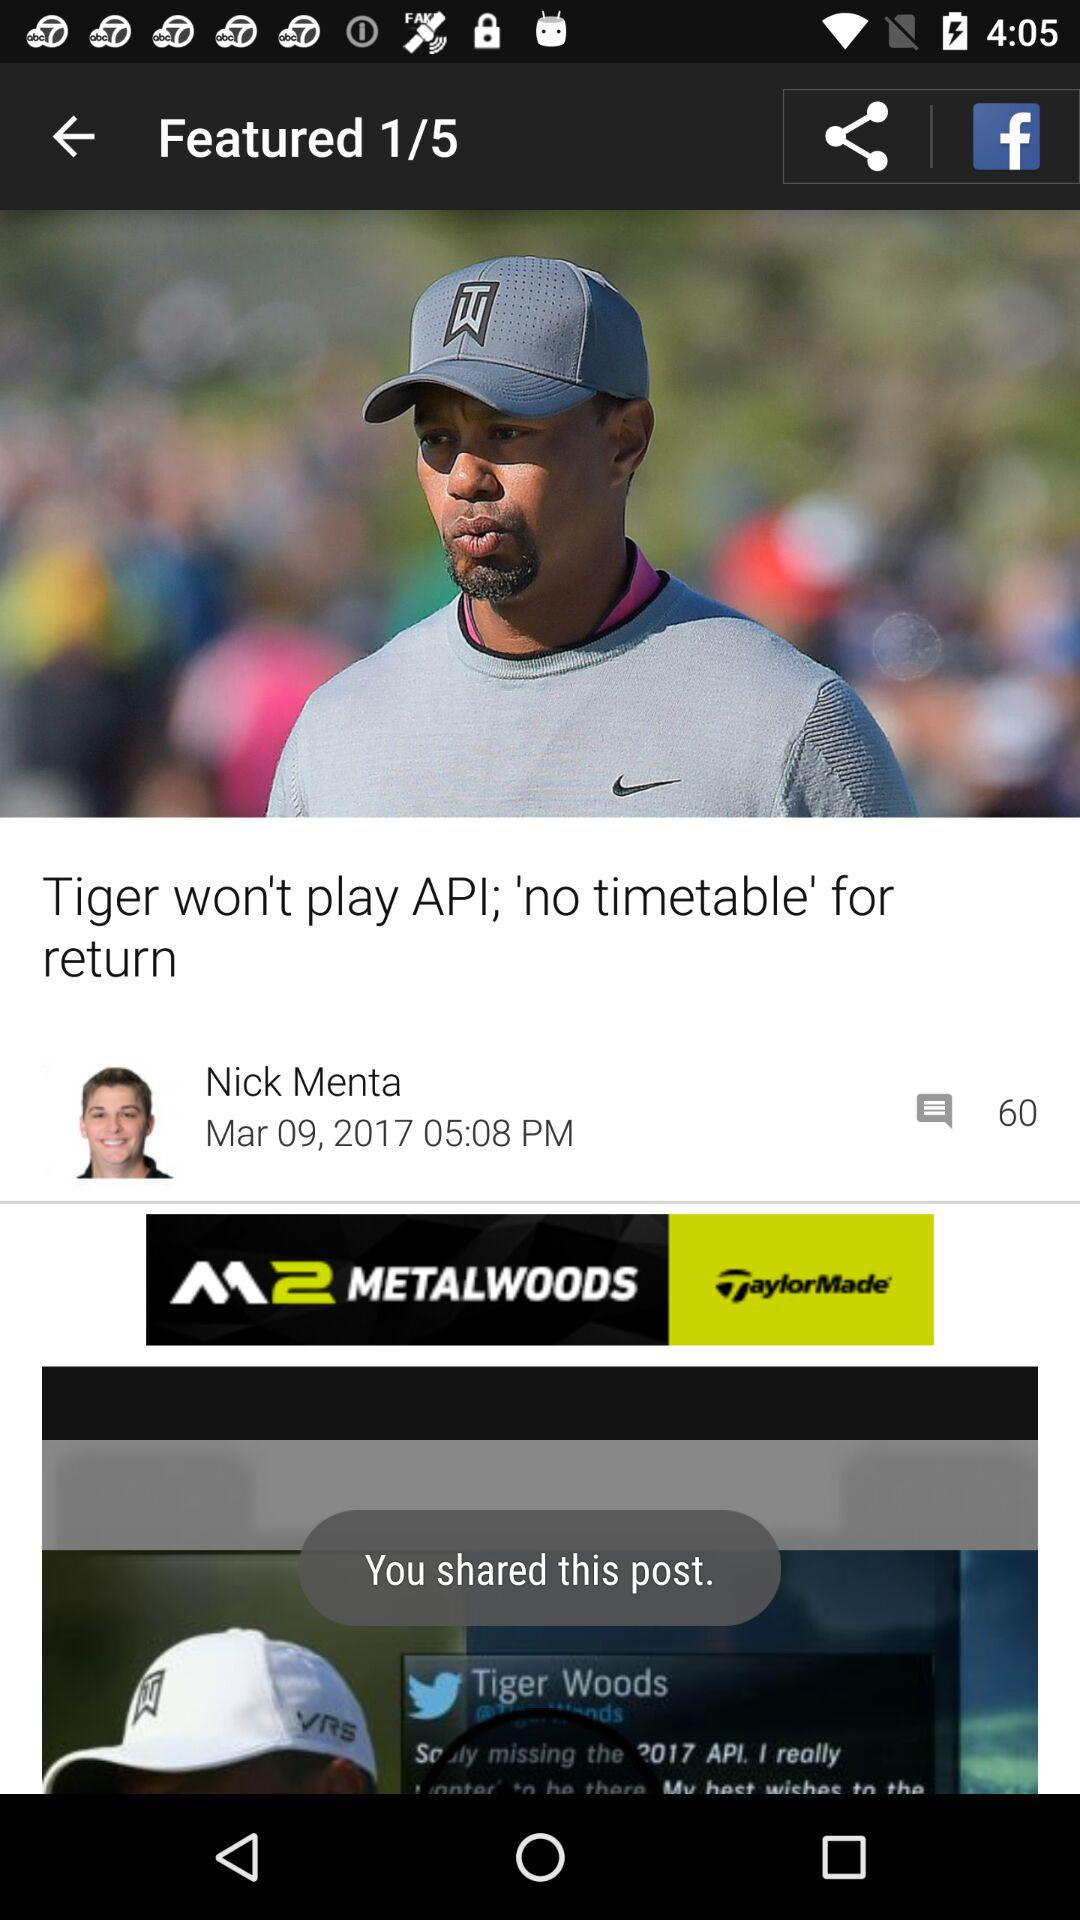What is the date? The date is March 9, 2017. 